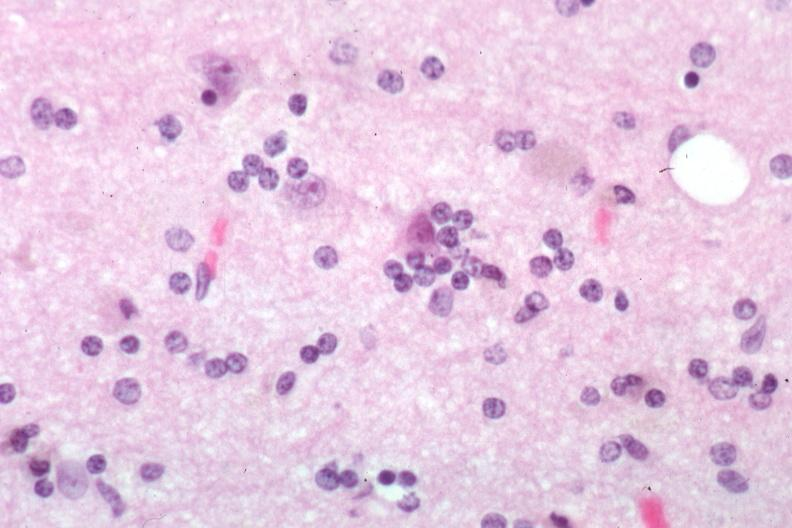s photo present?
Answer the question using a single word or phrase. No 